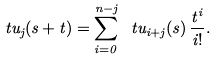Convert formula to latex. <formula><loc_0><loc_0><loc_500><loc_500>\ t u _ { j } ( s + t ) = \sum _ { i = 0 } ^ { n - j } \ t u _ { i + j } ( s ) \, \frac { t ^ { i } } { i ! } .</formula> 